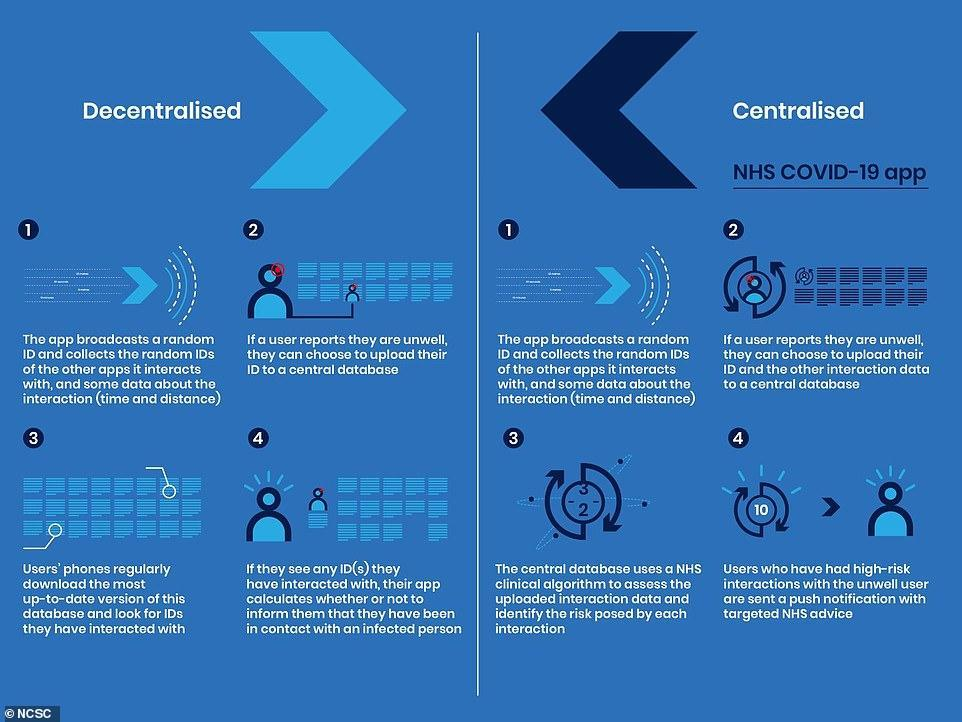how many steps of app processing are given in decentralized section?
Answer the question with a short phrase. 4 How many steps are common in both centralized and decentralized? 1 what is the second step in centralized? if a user reports they are unwell, they can choose to upload their ID and the other interaction data to a central database how many steps of app processing are given in centralized section? 4 what is the second step in decentralized? if a user reports they are unwell, they can choose to upload their ID to a central database 